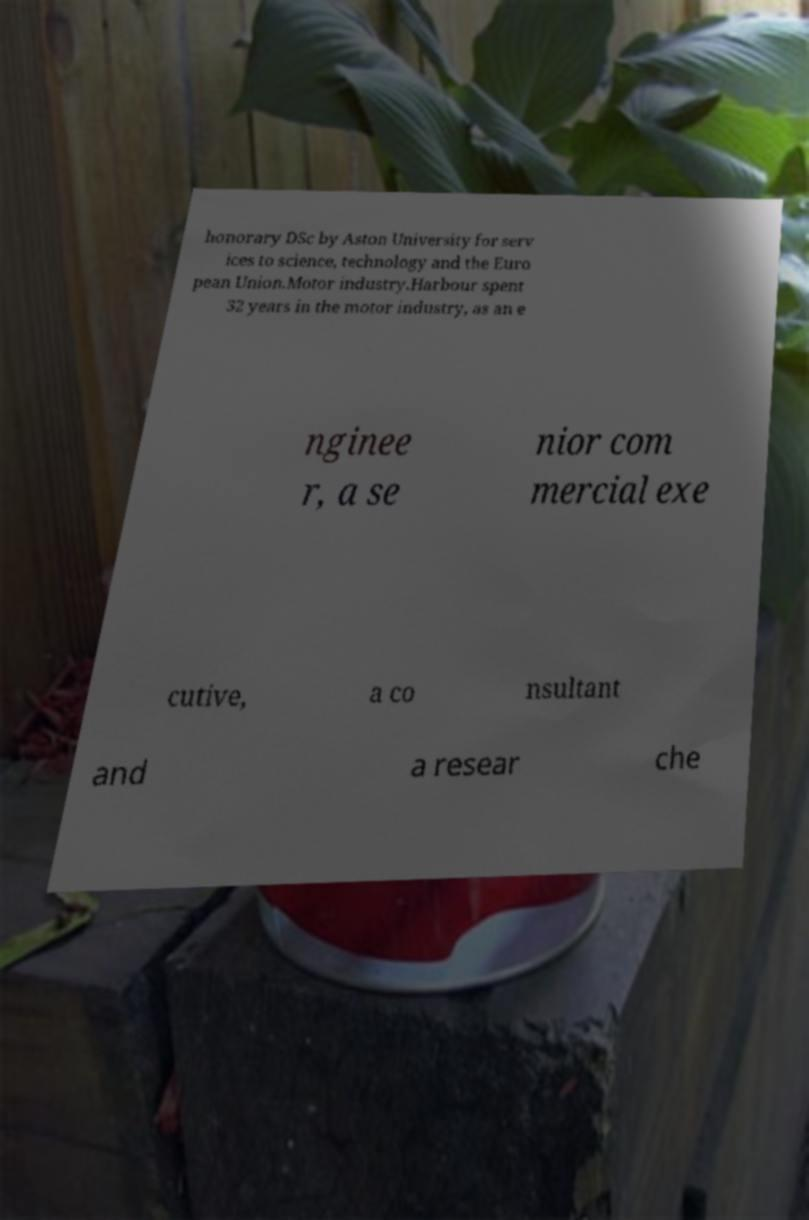What messages or text are displayed in this image? I need them in a readable, typed format. honorary DSc by Aston University for serv ices to science, technology and the Euro pean Union.Motor industry.Harbour spent 32 years in the motor industry, as an e nginee r, a se nior com mercial exe cutive, a co nsultant and a resear che 